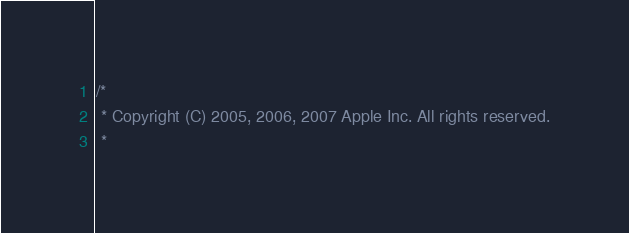<code> <loc_0><loc_0><loc_500><loc_500><_ObjectiveC_>/*
 * Copyright (C) 2005, 2006, 2007 Apple Inc. All rights reserved.
 *</code> 